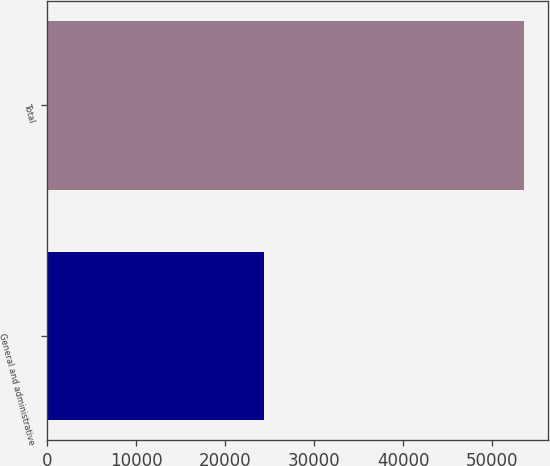Convert chart to OTSL. <chart><loc_0><loc_0><loc_500><loc_500><bar_chart><fcel>General and administrative<fcel>Total<nl><fcel>24356<fcel>53612<nl></chart> 